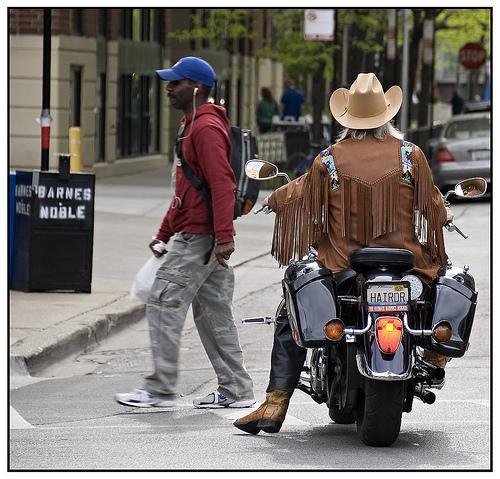How many people are wearing cowboy hats?
Give a very brief answer. 1. How many cars seen in the photo?
Give a very brief answer. 1. How many people are wearing blue hats?
Give a very brief answer. 1. 